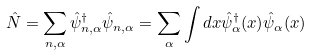Convert formula to latex. <formula><loc_0><loc_0><loc_500><loc_500>\hat { N } = \sum _ { { n } , \alpha } \hat { \psi } ^ { \dagger } _ { { n } , \alpha } \hat { \psi } _ { { n } , \alpha } = \sum _ { \alpha } \int d { x } \hat { \psi } ^ { \dagger } _ { \alpha } ( { x } ) \hat { \psi } _ { \alpha } ( { x } )</formula> 